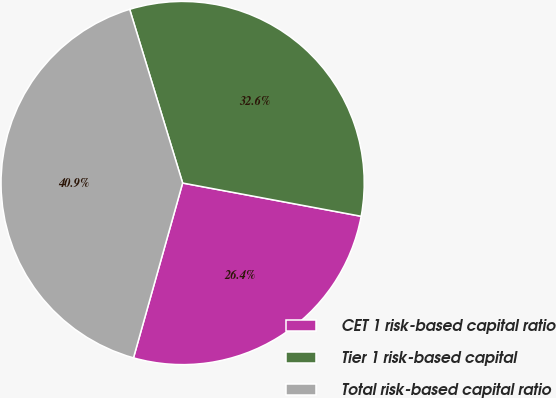<chart> <loc_0><loc_0><loc_500><loc_500><pie_chart><fcel>CET 1 risk-based capital ratio<fcel>Tier 1 risk-based capital<fcel>Total risk-based capital ratio<nl><fcel>26.43%<fcel>32.64%<fcel>40.93%<nl></chart> 